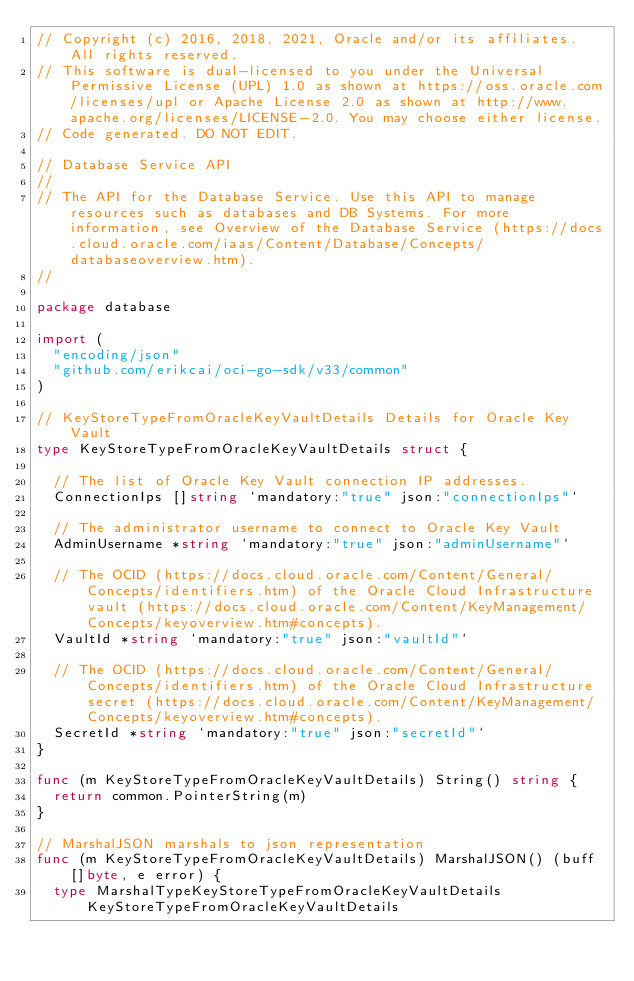Convert code to text. <code><loc_0><loc_0><loc_500><loc_500><_Go_>// Copyright (c) 2016, 2018, 2021, Oracle and/or its affiliates.  All rights reserved.
// This software is dual-licensed to you under the Universal Permissive License (UPL) 1.0 as shown at https://oss.oracle.com/licenses/upl or Apache License 2.0 as shown at http://www.apache.org/licenses/LICENSE-2.0. You may choose either license.
// Code generated. DO NOT EDIT.

// Database Service API
//
// The API for the Database Service. Use this API to manage resources such as databases and DB Systems. For more information, see Overview of the Database Service (https://docs.cloud.oracle.com/iaas/Content/Database/Concepts/databaseoverview.htm).
//

package database

import (
	"encoding/json"
	"github.com/erikcai/oci-go-sdk/v33/common"
)

// KeyStoreTypeFromOracleKeyVaultDetails Details for Oracle Key Vault
type KeyStoreTypeFromOracleKeyVaultDetails struct {

	// The list of Oracle Key Vault connection IP addresses.
	ConnectionIps []string `mandatory:"true" json:"connectionIps"`

	// The administrator username to connect to Oracle Key Vault
	AdminUsername *string `mandatory:"true" json:"adminUsername"`

	// The OCID (https://docs.cloud.oracle.com/Content/General/Concepts/identifiers.htm) of the Oracle Cloud Infrastructure vault (https://docs.cloud.oracle.com/Content/KeyManagement/Concepts/keyoverview.htm#concepts).
	VaultId *string `mandatory:"true" json:"vaultId"`

	// The OCID (https://docs.cloud.oracle.com/Content/General/Concepts/identifiers.htm) of the Oracle Cloud Infrastructure secret (https://docs.cloud.oracle.com/Content/KeyManagement/Concepts/keyoverview.htm#concepts).
	SecretId *string `mandatory:"true" json:"secretId"`
}

func (m KeyStoreTypeFromOracleKeyVaultDetails) String() string {
	return common.PointerString(m)
}

// MarshalJSON marshals to json representation
func (m KeyStoreTypeFromOracleKeyVaultDetails) MarshalJSON() (buff []byte, e error) {
	type MarshalTypeKeyStoreTypeFromOracleKeyVaultDetails KeyStoreTypeFromOracleKeyVaultDetails</code> 